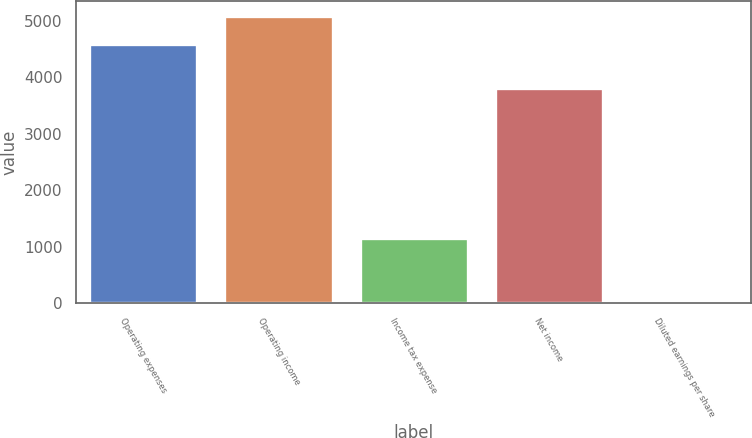<chart> <loc_0><loc_0><loc_500><loc_500><bar_chart><fcel>Operating expenses<fcel>Operating income<fcel>Income tax expense<fcel>Net income<fcel>Diluted earnings per share<nl><fcel>4589<fcel>5096.47<fcel>1150<fcel>3808<fcel>3.35<nl></chart> 